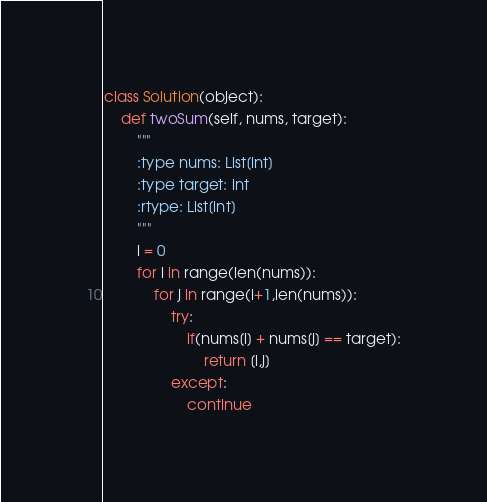Convert code to text. <code><loc_0><loc_0><loc_500><loc_500><_Python_>class Solution(object):
    def twoSum(self, nums, target):
        """
        :type nums: List[int]
        :type target: int
        :rtype: List[int]
        """
        i = 0
        for i in range(len(nums)):
            for j in range(i+1,len(nums)):
                try:
                    if(nums[i] + nums[j] == target):
                        return [i,j]
                except:
                    continue
</code> 